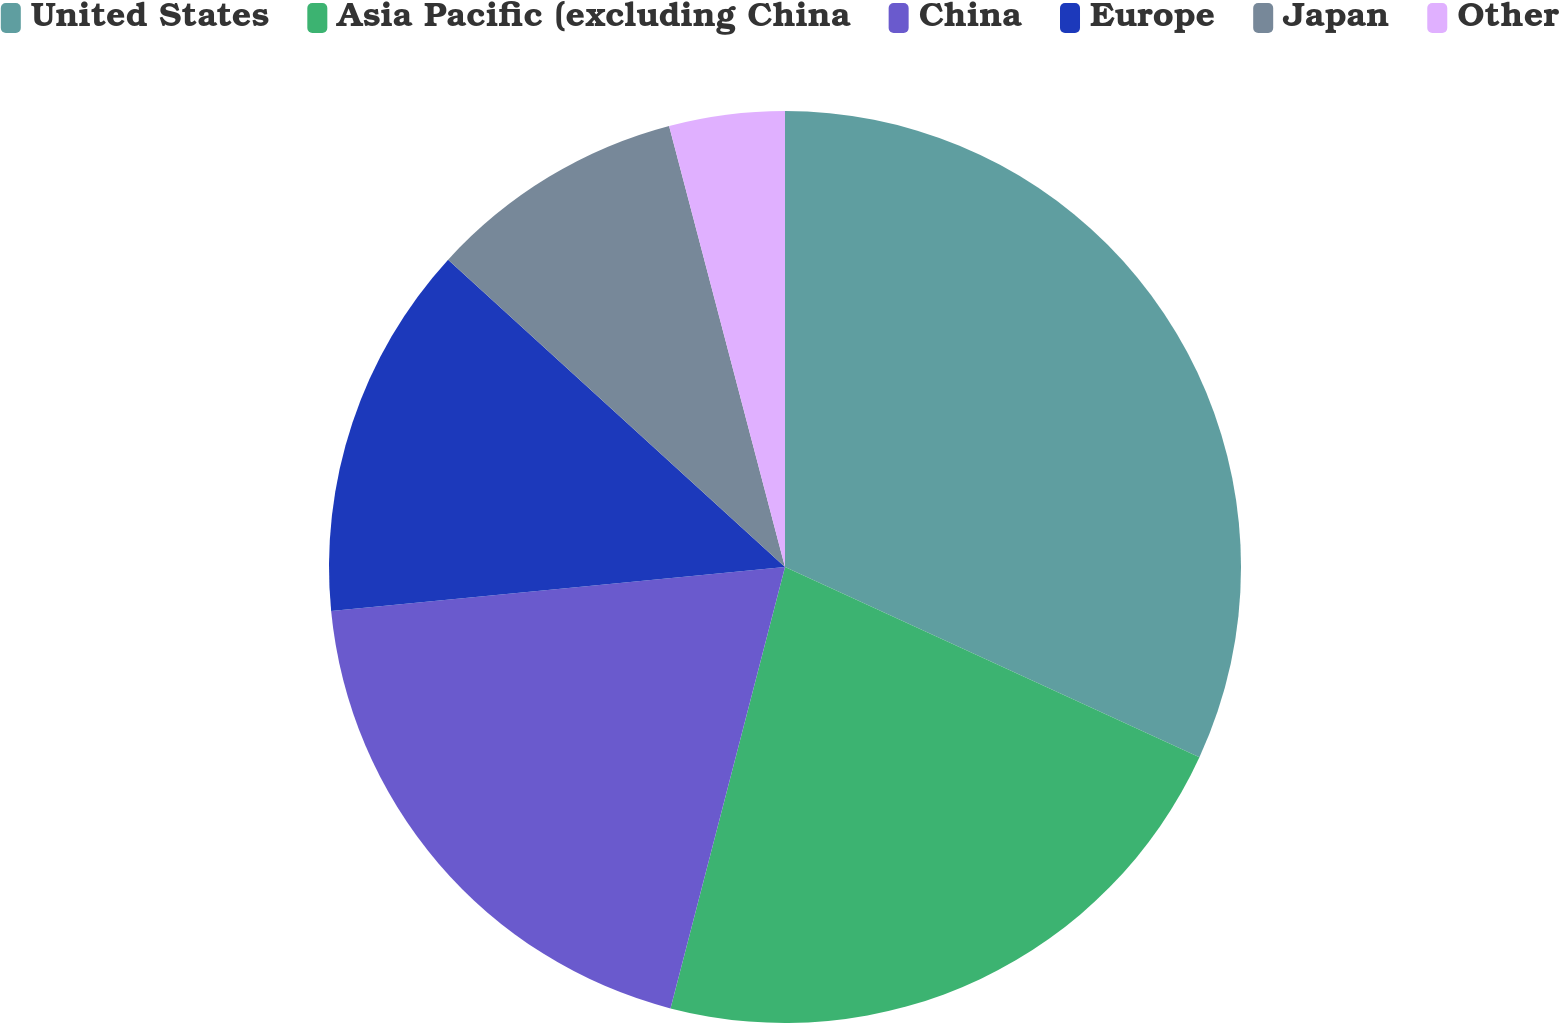Convert chart to OTSL. <chart><loc_0><loc_0><loc_500><loc_500><pie_chart><fcel>United States<fcel>Asia Pacific (excluding China<fcel>China<fcel>Europe<fcel>Japan<fcel>Other<nl><fcel>31.85%<fcel>22.19%<fcel>19.42%<fcel>13.31%<fcel>9.14%<fcel>4.09%<nl></chart> 